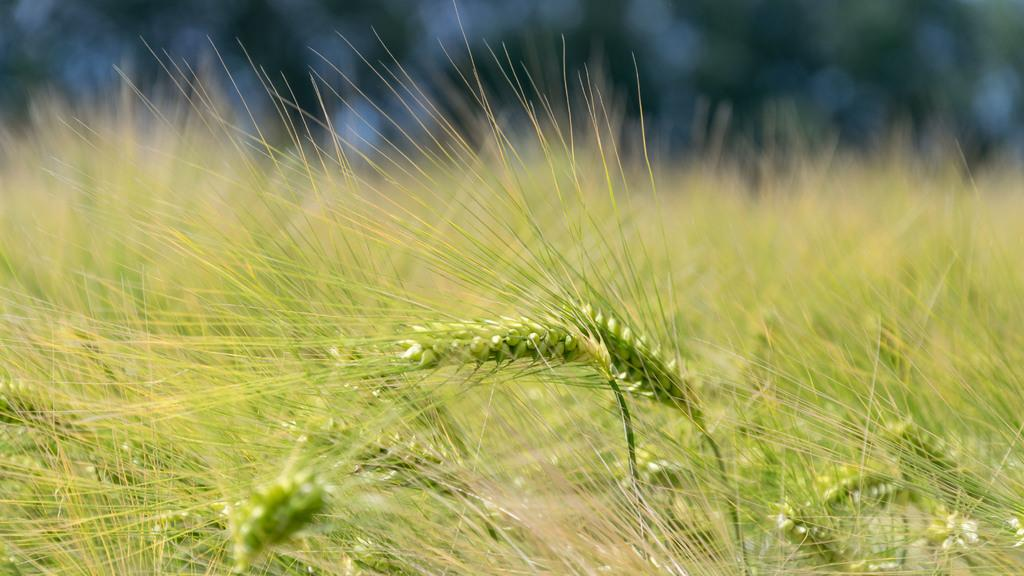What type of surface is visible in the image? There is grass on the surface in the image. What type of pancake is being used as a spy in the image? There is no pancake or spy present in the image; it only features a grassy surface. 